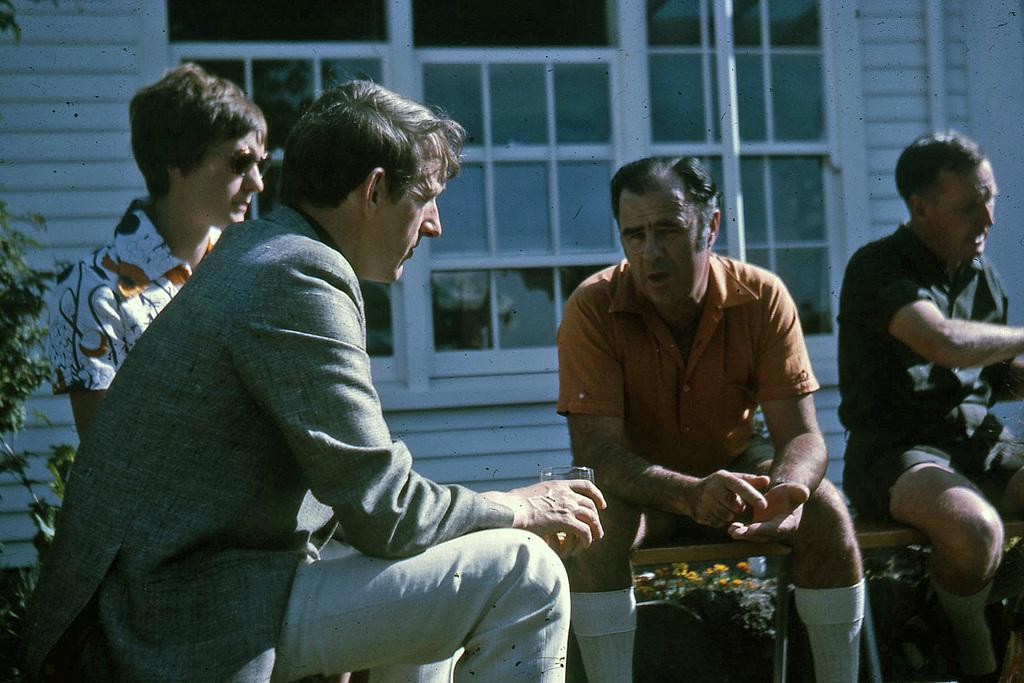What are the people in the image doing? There are persons sitting in the image. What is one person holding in their hands? One person is holding a glass in their hands. What type of window can be seen in the image? There is a glass window in the image. Where is the plant located in the image? There is a plant in the left corner of the image. How many tomatoes are on the card in the image? There is no card or tomatoes present in the image. 